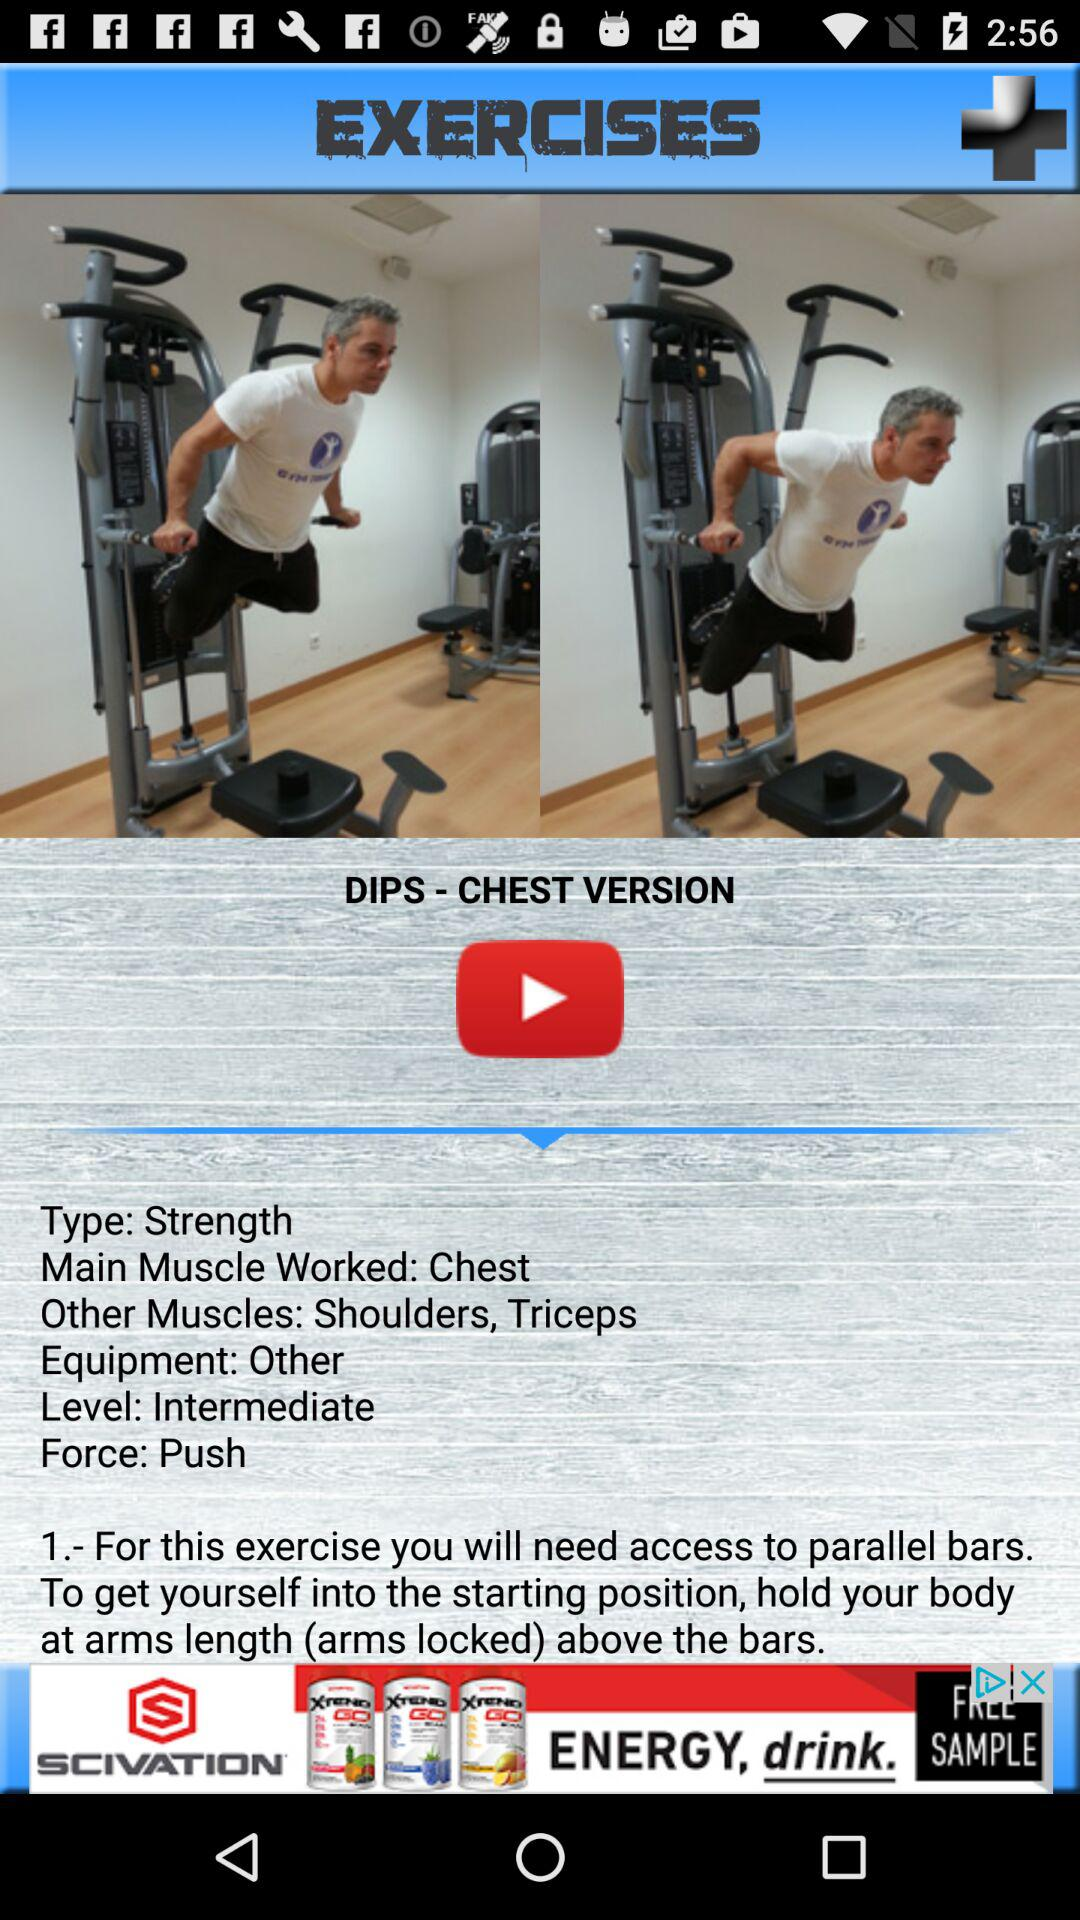What will you need access to for these exercises? You will need access to parallel bars. 